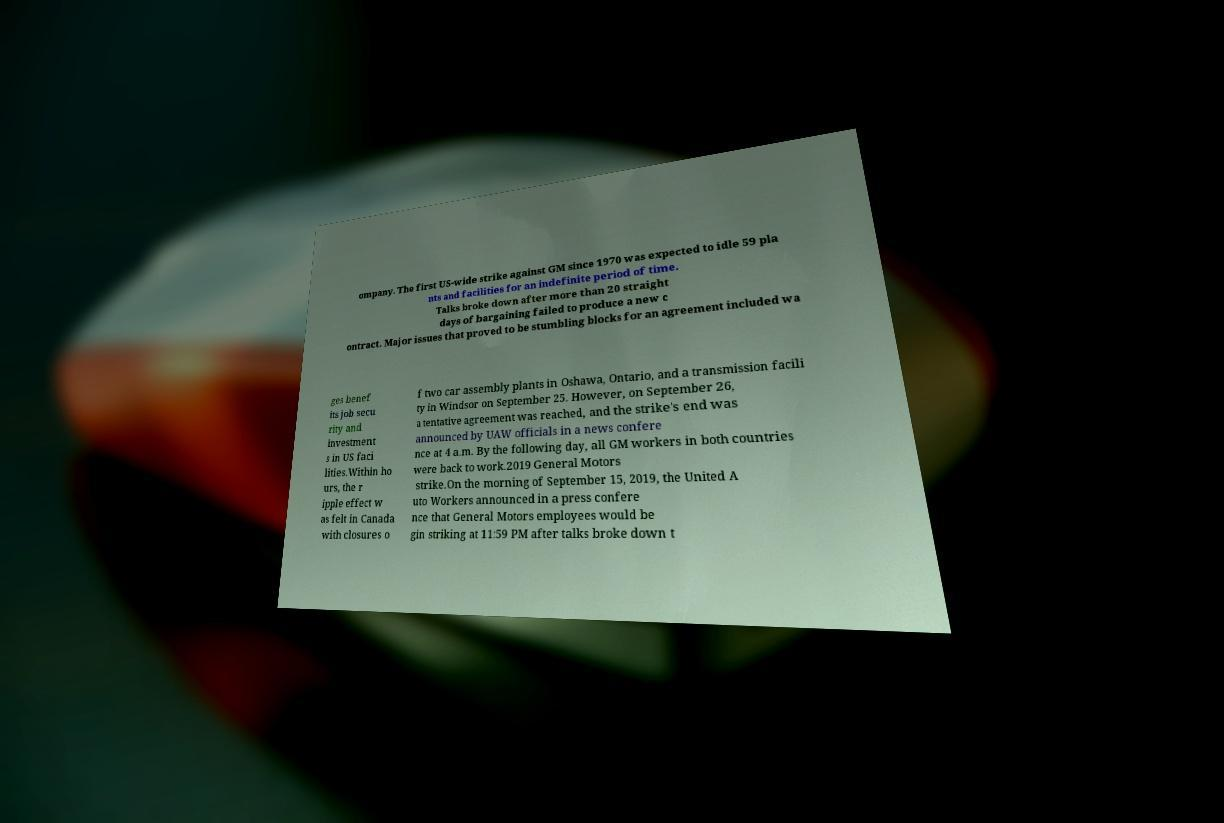Can you accurately transcribe the text from the provided image for me? ompany. The first US-wide strike against GM since 1970 was expected to idle 59 pla nts and facilities for an indefinite period of time. Talks broke down after more than 20 straight days of bargaining failed to produce a new c ontract. Major issues that proved to be stumbling blocks for an agreement included wa ges benef its job secu rity and investment s in US faci lities.Within ho urs, the r ipple effect w as felt in Canada with closures o f two car assembly plants in Oshawa, Ontario, and a transmission facili ty in Windsor on September 25. However, on September 26, a tentative agreement was reached, and the strike's end was announced by UAW officials in a news confere nce at 4 a.m. By the following day, all GM workers in both countries were back to work.2019 General Motors strike.On the morning of September 15, 2019, the United A uto Workers announced in a press confere nce that General Motors employees would be gin striking at 11:59 PM after talks broke down t 